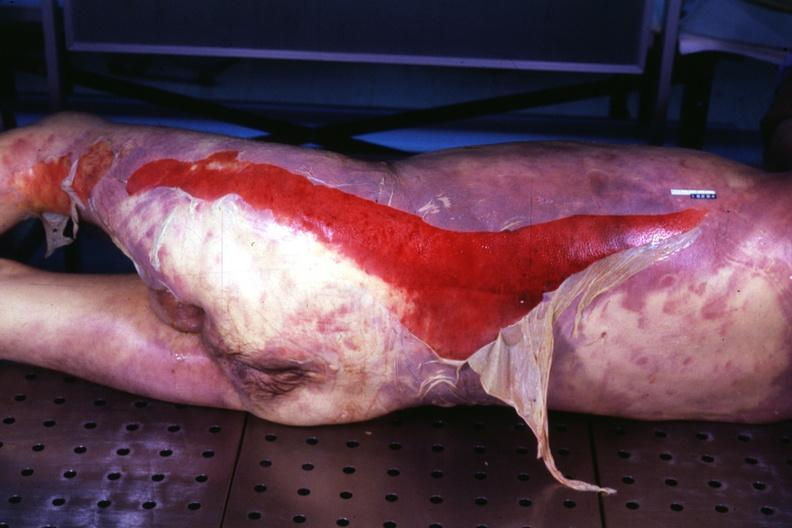does this image show portion of body with extensive skin desquamation same as in 907?
Answer the question using a single word or phrase. Yes 